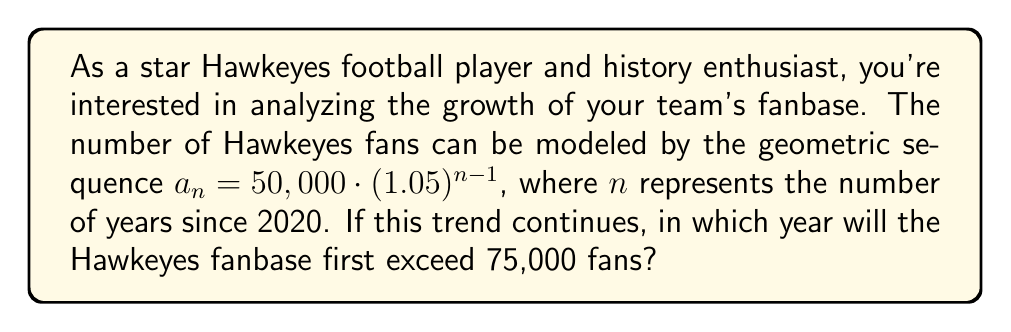Solve this math problem. To solve this problem, we need to find the smallest value of $n$ for which $a_n > 75,000$. Let's approach this step-by-step:

1) We start with the general term of the sequence:
   $a_n = 50,000 \cdot (1.05)^{n-1}$

2) We want to find $n$ where $a_n > 75,000$:
   $50,000 \cdot (1.05)^{n-1} > 75,000$

3) Divide both sides by 50,000:
   $(1.05)^{n-1} > 1.5$

4) Take the natural log of both sides:
   $(n-1) \cdot \ln(1.05) > \ln(1.5)$

5) Solve for $n$:
   $n-1 > \frac{\ln(1.5)}{\ln(1.05)}$
   $n > \frac{\ln(1.5)}{\ln(1.05)} + 1$

6) Calculate the right-hand side:
   $n > 8.3128...$

7) Since $n$ represents years and must be a whole number, we round up to the next integer:
   $n = 9$

8) This means the fanbase will exceed 75,000 in the 9th year after 2020.

9) Therefore, 2020 + 9 = 2029 is the year when the fanbase will first exceed 75,000.
Answer: The Hawkeyes fanbase will first exceed 75,000 fans in 2029. 